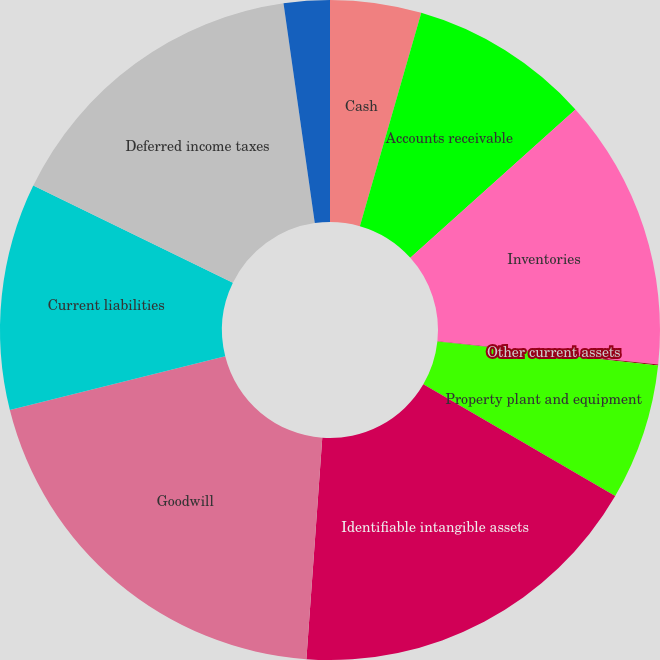<chart> <loc_0><loc_0><loc_500><loc_500><pie_chart><fcel>Cash<fcel>Accounts receivable<fcel>Inventories<fcel>Other current assets<fcel>Property plant and equipment<fcel>Identifiable intangible assets<fcel>Goodwill<fcel>Current liabilities<fcel>Deferred income taxes<fcel>Other liabilities<nl><fcel>4.46%<fcel>8.89%<fcel>13.32%<fcel>0.04%<fcel>6.68%<fcel>17.75%<fcel>19.96%<fcel>11.11%<fcel>15.54%<fcel>2.25%<nl></chart> 